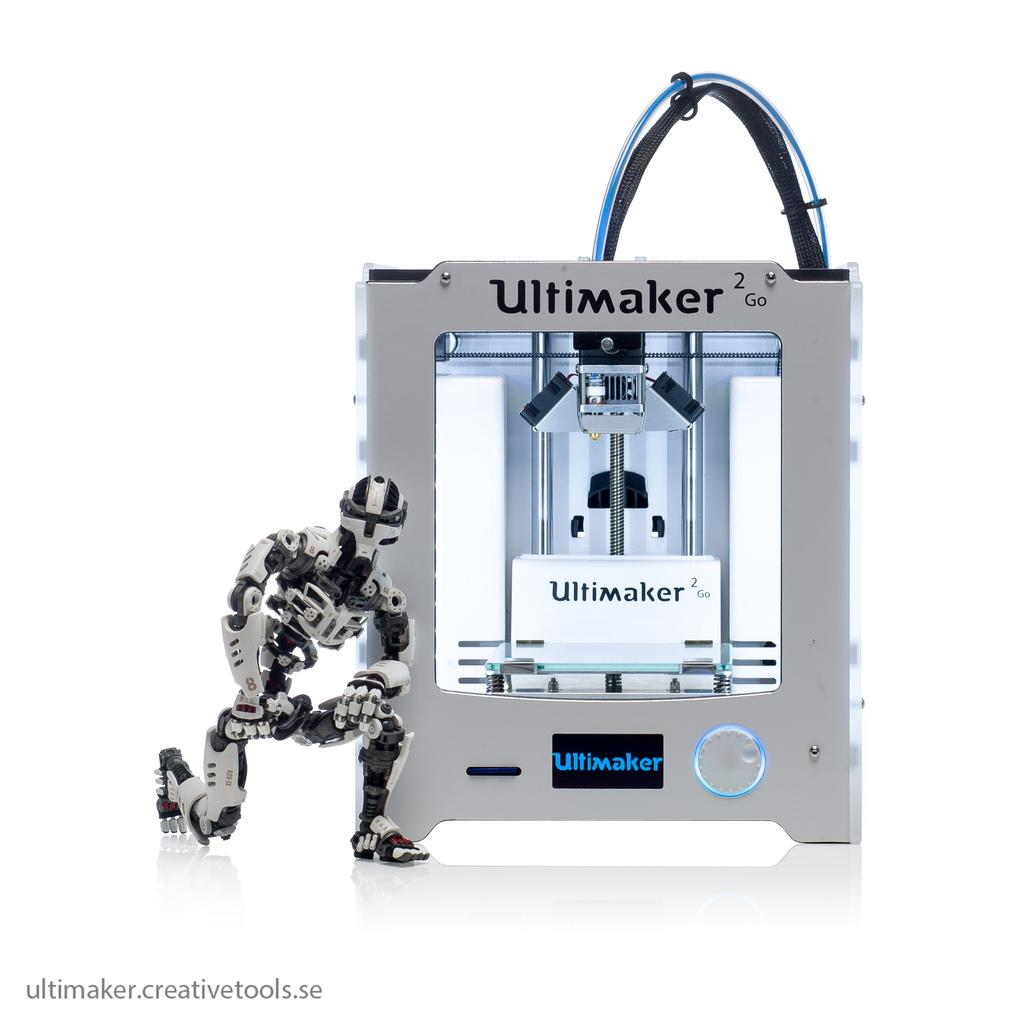What type of object can be seen in the image? There is a toy in the image. What colors are present on the toy? The toy has white and black colors. What other object is visible in the image? There is a machine in the image. What color is the machine? The machine has a white color. What is the color of the background in the image? The background of the image is white. Can you see any giants in the image? There are no giants present in the image. What type of throat is visible in the image? There is no throat visible in the image. 